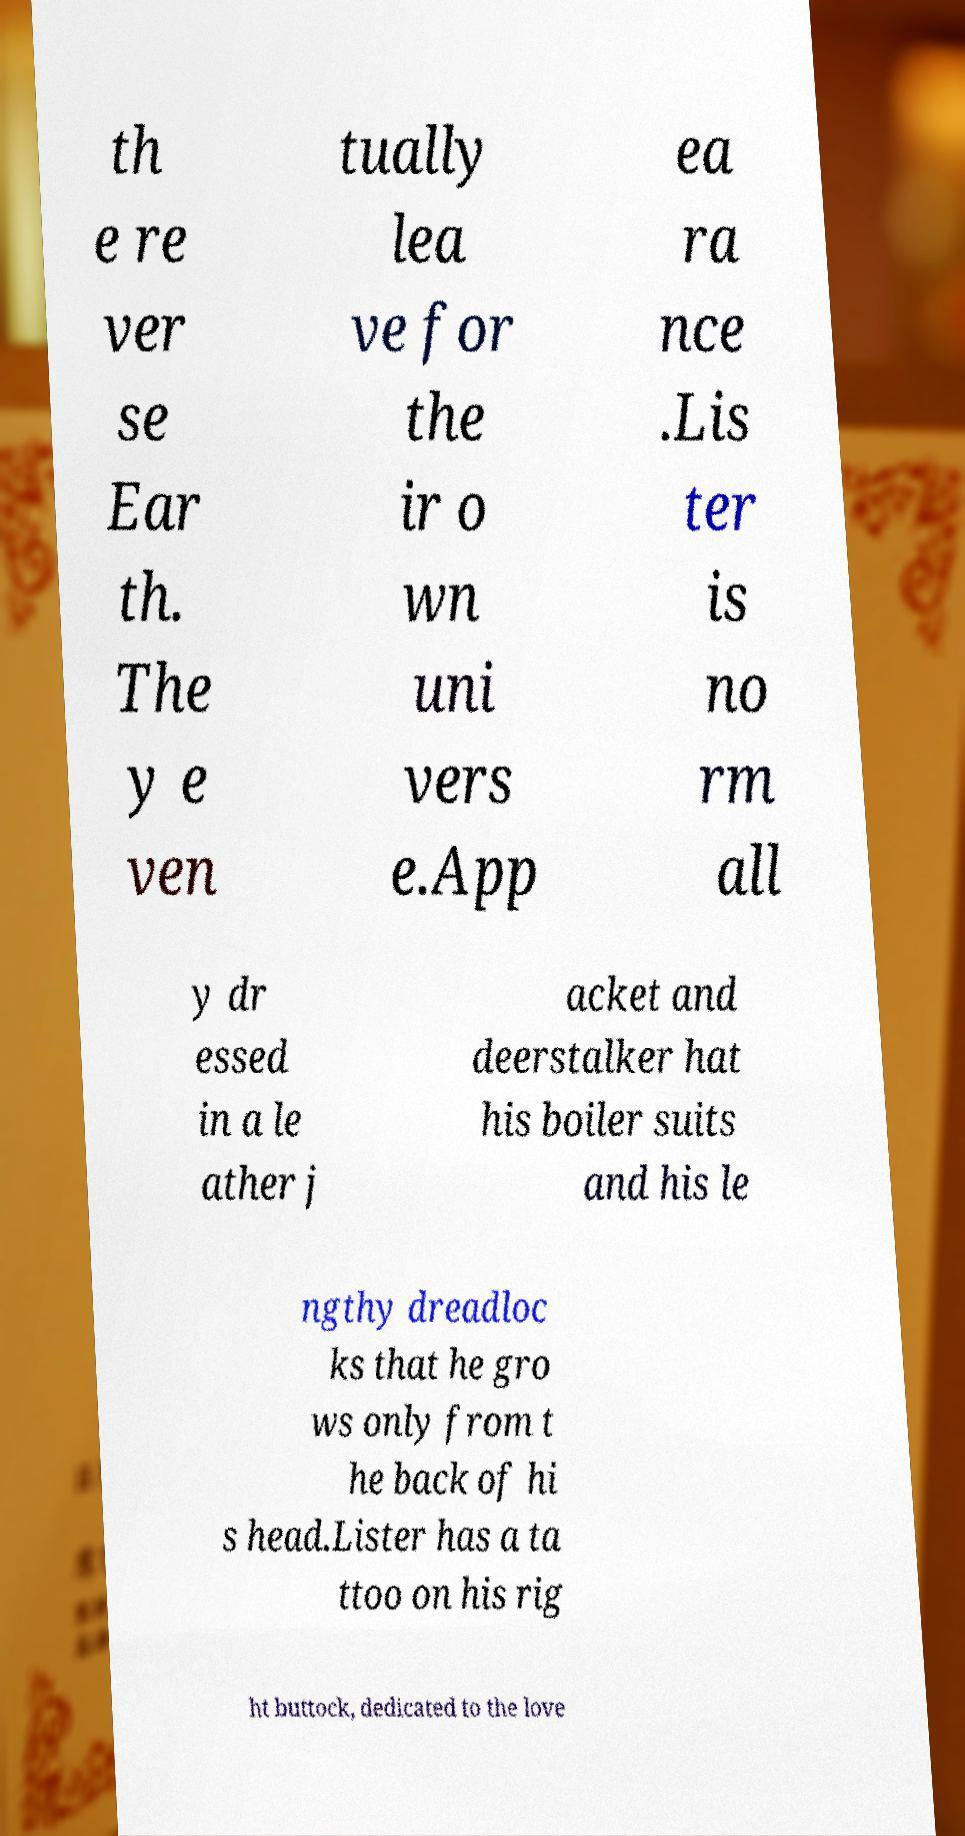Can you read and provide the text displayed in the image?This photo seems to have some interesting text. Can you extract and type it out for me? th e re ver se Ear th. The y e ven tually lea ve for the ir o wn uni vers e.App ea ra nce .Lis ter is no rm all y dr essed in a le ather j acket and deerstalker hat his boiler suits and his le ngthy dreadloc ks that he gro ws only from t he back of hi s head.Lister has a ta ttoo on his rig ht buttock, dedicated to the love 